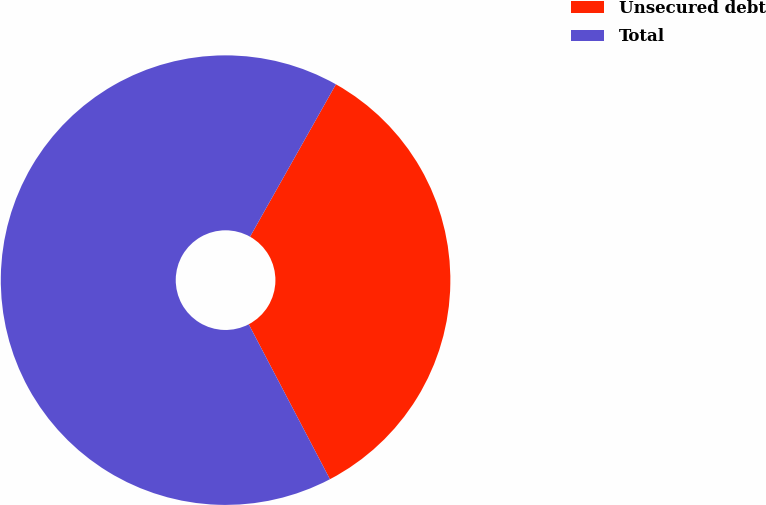Convert chart to OTSL. <chart><loc_0><loc_0><loc_500><loc_500><pie_chart><fcel>Unsecured debt<fcel>Total<nl><fcel>34.15%<fcel>65.85%<nl></chart> 